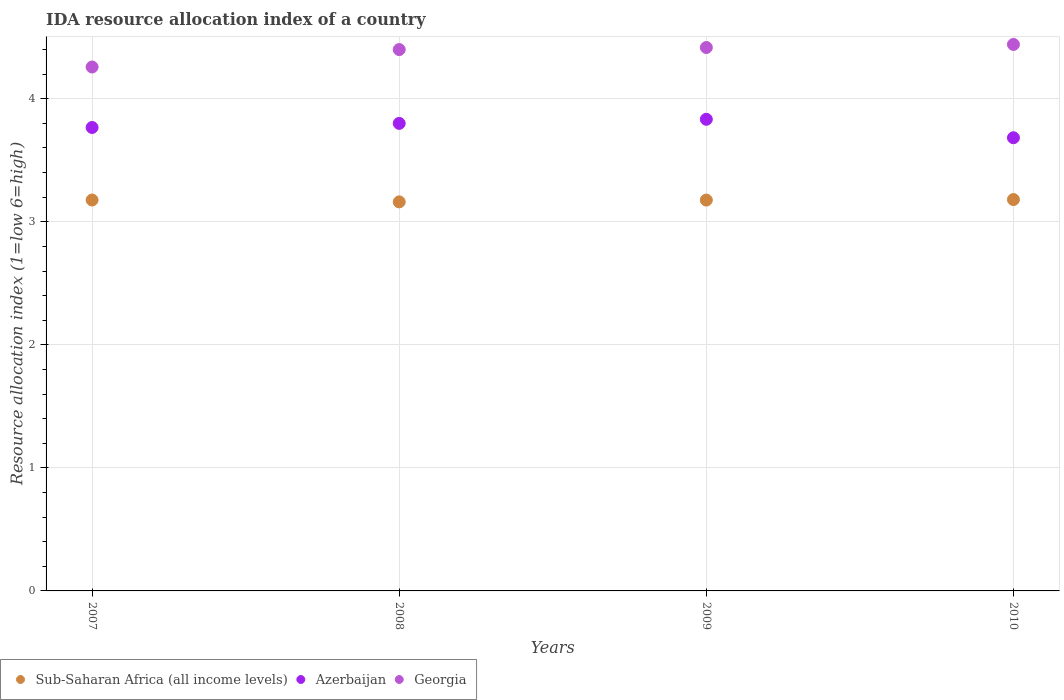What is the IDA resource allocation index in Azerbaijan in 2007?
Give a very brief answer. 3.77. Across all years, what is the maximum IDA resource allocation index in Azerbaijan?
Give a very brief answer. 3.83. Across all years, what is the minimum IDA resource allocation index in Sub-Saharan Africa (all income levels)?
Ensure brevity in your answer.  3.16. In which year was the IDA resource allocation index in Georgia maximum?
Your response must be concise. 2010. In which year was the IDA resource allocation index in Azerbaijan minimum?
Ensure brevity in your answer.  2010. What is the total IDA resource allocation index in Azerbaijan in the graph?
Offer a terse response. 15.08. What is the difference between the IDA resource allocation index in Azerbaijan in 2008 and that in 2009?
Ensure brevity in your answer.  -0.03. What is the difference between the IDA resource allocation index in Sub-Saharan Africa (all income levels) in 2010 and the IDA resource allocation index in Georgia in 2009?
Give a very brief answer. -1.24. What is the average IDA resource allocation index in Azerbaijan per year?
Make the answer very short. 3.77. In the year 2010, what is the difference between the IDA resource allocation index in Georgia and IDA resource allocation index in Azerbaijan?
Offer a terse response. 0.76. In how many years, is the IDA resource allocation index in Azerbaijan greater than 3.6?
Give a very brief answer. 4. What is the ratio of the IDA resource allocation index in Azerbaijan in 2008 to that in 2010?
Provide a short and direct response. 1.03. Is the IDA resource allocation index in Sub-Saharan Africa (all income levels) in 2007 less than that in 2010?
Give a very brief answer. Yes. What is the difference between the highest and the second highest IDA resource allocation index in Azerbaijan?
Your answer should be very brief. 0.03. What is the difference between the highest and the lowest IDA resource allocation index in Sub-Saharan Africa (all income levels)?
Ensure brevity in your answer.  0.02. Is it the case that in every year, the sum of the IDA resource allocation index in Azerbaijan and IDA resource allocation index in Sub-Saharan Africa (all income levels)  is greater than the IDA resource allocation index in Georgia?
Provide a succinct answer. Yes. Does the IDA resource allocation index in Georgia monotonically increase over the years?
Provide a short and direct response. Yes. Is the IDA resource allocation index in Azerbaijan strictly less than the IDA resource allocation index in Georgia over the years?
Keep it short and to the point. Yes. How many dotlines are there?
Give a very brief answer. 3. How many years are there in the graph?
Offer a terse response. 4. What is the difference between two consecutive major ticks on the Y-axis?
Provide a short and direct response. 1. How many legend labels are there?
Offer a very short reply. 3. How are the legend labels stacked?
Provide a succinct answer. Horizontal. What is the title of the graph?
Give a very brief answer. IDA resource allocation index of a country. Does "Malaysia" appear as one of the legend labels in the graph?
Your response must be concise. No. What is the label or title of the X-axis?
Offer a very short reply. Years. What is the label or title of the Y-axis?
Provide a succinct answer. Resource allocation index (1=low 6=high). What is the Resource allocation index (1=low 6=high) in Sub-Saharan Africa (all income levels) in 2007?
Keep it short and to the point. 3.18. What is the Resource allocation index (1=low 6=high) in Azerbaijan in 2007?
Ensure brevity in your answer.  3.77. What is the Resource allocation index (1=low 6=high) of Georgia in 2007?
Ensure brevity in your answer.  4.26. What is the Resource allocation index (1=low 6=high) of Sub-Saharan Africa (all income levels) in 2008?
Make the answer very short. 3.16. What is the Resource allocation index (1=low 6=high) in Azerbaijan in 2008?
Your answer should be very brief. 3.8. What is the Resource allocation index (1=low 6=high) in Georgia in 2008?
Your answer should be compact. 4.4. What is the Resource allocation index (1=low 6=high) of Sub-Saharan Africa (all income levels) in 2009?
Provide a short and direct response. 3.18. What is the Resource allocation index (1=low 6=high) of Azerbaijan in 2009?
Offer a terse response. 3.83. What is the Resource allocation index (1=low 6=high) of Georgia in 2009?
Offer a terse response. 4.42. What is the Resource allocation index (1=low 6=high) in Sub-Saharan Africa (all income levels) in 2010?
Keep it short and to the point. 3.18. What is the Resource allocation index (1=low 6=high) in Azerbaijan in 2010?
Your response must be concise. 3.68. What is the Resource allocation index (1=low 6=high) in Georgia in 2010?
Provide a short and direct response. 4.44. Across all years, what is the maximum Resource allocation index (1=low 6=high) in Sub-Saharan Africa (all income levels)?
Your response must be concise. 3.18. Across all years, what is the maximum Resource allocation index (1=low 6=high) in Azerbaijan?
Keep it short and to the point. 3.83. Across all years, what is the maximum Resource allocation index (1=low 6=high) in Georgia?
Your answer should be very brief. 4.44. Across all years, what is the minimum Resource allocation index (1=low 6=high) of Sub-Saharan Africa (all income levels)?
Your answer should be very brief. 3.16. Across all years, what is the minimum Resource allocation index (1=low 6=high) of Azerbaijan?
Give a very brief answer. 3.68. Across all years, what is the minimum Resource allocation index (1=low 6=high) of Georgia?
Provide a short and direct response. 4.26. What is the total Resource allocation index (1=low 6=high) in Sub-Saharan Africa (all income levels) in the graph?
Your response must be concise. 12.7. What is the total Resource allocation index (1=low 6=high) in Azerbaijan in the graph?
Make the answer very short. 15.08. What is the total Resource allocation index (1=low 6=high) of Georgia in the graph?
Your response must be concise. 17.52. What is the difference between the Resource allocation index (1=low 6=high) of Sub-Saharan Africa (all income levels) in 2007 and that in 2008?
Provide a short and direct response. 0.02. What is the difference between the Resource allocation index (1=low 6=high) in Azerbaijan in 2007 and that in 2008?
Offer a terse response. -0.03. What is the difference between the Resource allocation index (1=low 6=high) of Georgia in 2007 and that in 2008?
Offer a very short reply. -0.14. What is the difference between the Resource allocation index (1=low 6=high) of Sub-Saharan Africa (all income levels) in 2007 and that in 2009?
Keep it short and to the point. 0. What is the difference between the Resource allocation index (1=low 6=high) in Azerbaijan in 2007 and that in 2009?
Provide a succinct answer. -0.07. What is the difference between the Resource allocation index (1=low 6=high) in Georgia in 2007 and that in 2009?
Give a very brief answer. -0.16. What is the difference between the Resource allocation index (1=low 6=high) of Sub-Saharan Africa (all income levels) in 2007 and that in 2010?
Your response must be concise. -0. What is the difference between the Resource allocation index (1=low 6=high) of Azerbaijan in 2007 and that in 2010?
Your answer should be very brief. 0.08. What is the difference between the Resource allocation index (1=low 6=high) of Georgia in 2007 and that in 2010?
Provide a succinct answer. -0.18. What is the difference between the Resource allocation index (1=low 6=high) of Sub-Saharan Africa (all income levels) in 2008 and that in 2009?
Your response must be concise. -0.01. What is the difference between the Resource allocation index (1=low 6=high) in Azerbaijan in 2008 and that in 2009?
Provide a succinct answer. -0.03. What is the difference between the Resource allocation index (1=low 6=high) of Georgia in 2008 and that in 2009?
Your answer should be compact. -0.02. What is the difference between the Resource allocation index (1=low 6=high) of Sub-Saharan Africa (all income levels) in 2008 and that in 2010?
Provide a short and direct response. -0.02. What is the difference between the Resource allocation index (1=low 6=high) of Azerbaijan in 2008 and that in 2010?
Offer a very short reply. 0.12. What is the difference between the Resource allocation index (1=low 6=high) in Georgia in 2008 and that in 2010?
Offer a very short reply. -0.04. What is the difference between the Resource allocation index (1=low 6=high) in Sub-Saharan Africa (all income levels) in 2009 and that in 2010?
Provide a succinct answer. -0. What is the difference between the Resource allocation index (1=low 6=high) of Georgia in 2009 and that in 2010?
Offer a very short reply. -0.03. What is the difference between the Resource allocation index (1=low 6=high) of Sub-Saharan Africa (all income levels) in 2007 and the Resource allocation index (1=low 6=high) of Azerbaijan in 2008?
Give a very brief answer. -0.62. What is the difference between the Resource allocation index (1=low 6=high) in Sub-Saharan Africa (all income levels) in 2007 and the Resource allocation index (1=low 6=high) in Georgia in 2008?
Give a very brief answer. -1.22. What is the difference between the Resource allocation index (1=low 6=high) of Azerbaijan in 2007 and the Resource allocation index (1=low 6=high) of Georgia in 2008?
Your answer should be very brief. -0.63. What is the difference between the Resource allocation index (1=low 6=high) in Sub-Saharan Africa (all income levels) in 2007 and the Resource allocation index (1=low 6=high) in Azerbaijan in 2009?
Your response must be concise. -0.66. What is the difference between the Resource allocation index (1=low 6=high) in Sub-Saharan Africa (all income levels) in 2007 and the Resource allocation index (1=low 6=high) in Georgia in 2009?
Offer a very short reply. -1.24. What is the difference between the Resource allocation index (1=low 6=high) of Azerbaijan in 2007 and the Resource allocation index (1=low 6=high) of Georgia in 2009?
Ensure brevity in your answer.  -0.65. What is the difference between the Resource allocation index (1=low 6=high) in Sub-Saharan Africa (all income levels) in 2007 and the Resource allocation index (1=low 6=high) in Azerbaijan in 2010?
Ensure brevity in your answer.  -0.51. What is the difference between the Resource allocation index (1=low 6=high) of Sub-Saharan Africa (all income levels) in 2007 and the Resource allocation index (1=low 6=high) of Georgia in 2010?
Provide a short and direct response. -1.26. What is the difference between the Resource allocation index (1=low 6=high) in Azerbaijan in 2007 and the Resource allocation index (1=low 6=high) in Georgia in 2010?
Your response must be concise. -0.68. What is the difference between the Resource allocation index (1=low 6=high) of Sub-Saharan Africa (all income levels) in 2008 and the Resource allocation index (1=low 6=high) of Azerbaijan in 2009?
Your answer should be very brief. -0.67. What is the difference between the Resource allocation index (1=low 6=high) in Sub-Saharan Africa (all income levels) in 2008 and the Resource allocation index (1=low 6=high) in Georgia in 2009?
Your answer should be compact. -1.25. What is the difference between the Resource allocation index (1=low 6=high) of Azerbaijan in 2008 and the Resource allocation index (1=low 6=high) of Georgia in 2009?
Your answer should be very brief. -0.62. What is the difference between the Resource allocation index (1=low 6=high) of Sub-Saharan Africa (all income levels) in 2008 and the Resource allocation index (1=low 6=high) of Azerbaijan in 2010?
Your answer should be compact. -0.52. What is the difference between the Resource allocation index (1=low 6=high) of Sub-Saharan Africa (all income levels) in 2008 and the Resource allocation index (1=low 6=high) of Georgia in 2010?
Offer a terse response. -1.28. What is the difference between the Resource allocation index (1=low 6=high) in Azerbaijan in 2008 and the Resource allocation index (1=low 6=high) in Georgia in 2010?
Your response must be concise. -0.64. What is the difference between the Resource allocation index (1=low 6=high) of Sub-Saharan Africa (all income levels) in 2009 and the Resource allocation index (1=low 6=high) of Azerbaijan in 2010?
Your response must be concise. -0.51. What is the difference between the Resource allocation index (1=low 6=high) of Sub-Saharan Africa (all income levels) in 2009 and the Resource allocation index (1=low 6=high) of Georgia in 2010?
Ensure brevity in your answer.  -1.26. What is the difference between the Resource allocation index (1=low 6=high) in Azerbaijan in 2009 and the Resource allocation index (1=low 6=high) in Georgia in 2010?
Keep it short and to the point. -0.61. What is the average Resource allocation index (1=low 6=high) in Sub-Saharan Africa (all income levels) per year?
Ensure brevity in your answer.  3.17. What is the average Resource allocation index (1=low 6=high) of Azerbaijan per year?
Keep it short and to the point. 3.77. What is the average Resource allocation index (1=low 6=high) of Georgia per year?
Make the answer very short. 4.38. In the year 2007, what is the difference between the Resource allocation index (1=low 6=high) of Sub-Saharan Africa (all income levels) and Resource allocation index (1=low 6=high) of Azerbaijan?
Your response must be concise. -0.59. In the year 2007, what is the difference between the Resource allocation index (1=low 6=high) of Sub-Saharan Africa (all income levels) and Resource allocation index (1=low 6=high) of Georgia?
Your answer should be compact. -1.08. In the year 2007, what is the difference between the Resource allocation index (1=low 6=high) in Azerbaijan and Resource allocation index (1=low 6=high) in Georgia?
Keep it short and to the point. -0.49. In the year 2008, what is the difference between the Resource allocation index (1=low 6=high) of Sub-Saharan Africa (all income levels) and Resource allocation index (1=low 6=high) of Azerbaijan?
Make the answer very short. -0.64. In the year 2008, what is the difference between the Resource allocation index (1=low 6=high) in Sub-Saharan Africa (all income levels) and Resource allocation index (1=low 6=high) in Georgia?
Ensure brevity in your answer.  -1.24. In the year 2008, what is the difference between the Resource allocation index (1=low 6=high) of Azerbaijan and Resource allocation index (1=low 6=high) of Georgia?
Your answer should be very brief. -0.6. In the year 2009, what is the difference between the Resource allocation index (1=low 6=high) in Sub-Saharan Africa (all income levels) and Resource allocation index (1=low 6=high) in Azerbaijan?
Provide a short and direct response. -0.66. In the year 2009, what is the difference between the Resource allocation index (1=low 6=high) in Sub-Saharan Africa (all income levels) and Resource allocation index (1=low 6=high) in Georgia?
Give a very brief answer. -1.24. In the year 2009, what is the difference between the Resource allocation index (1=low 6=high) in Azerbaijan and Resource allocation index (1=low 6=high) in Georgia?
Ensure brevity in your answer.  -0.58. In the year 2010, what is the difference between the Resource allocation index (1=low 6=high) of Sub-Saharan Africa (all income levels) and Resource allocation index (1=low 6=high) of Azerbaijan?
Provide a short and direct response. -0.5. In the year 2010, what is the difference between the Resource allocation index (1=low 6=high) of Sub-Saharan Africa (all income levels) and Resource allocation index (1=low 6=high) of Georgia?
Make the answer very short. -1.26. In the year 2010, what is the difference between the Resource allocation index (1=low 6=high) in Azerbaijan and Resource allocation index (1=low 6=high) in Georgia?
Make the answer very short. -0.76. What is the ratio of the Resource allocation index (1=low 6=high) of Azerbaijan in 2007 to that in 2008?
Make the answer very short. 0.99. What is the ratio of the Resource allocation index (1=low 6=high) of Georgia in 2007 to that in 2008?
Give a very brief answer. 0.97. What is the ratio of the Resource allocation index (1=low 6=high) of Azerbaijan in 2007 to that in 2009?
Ensure brevity in your answer.  0.98. What is the ratio of the Resource allocation index (1=low 6=high) of Georgia in 2007 to that in 2009?
Provide a succinct answer. 0.96. What is the ratio of the Resource allocation index (1=low 6=high) in Azerbaijan in 2007 to that in 2010?
Your response must be concise. 1.02. What is the ratio of the Resource allocation index (1=low 6=high) in Georgia in 2007 to that in 2010?
Give a very brief answer. 0.96. What is the ratio of the Resource allocation index (1=low 6=high) of Sub-Saharan Africa (all income levels) in 2008 to that in 2009?
Your answer should be very brief. 1. What is the ratio of the Resource allocation index (1=low 6=high) in Azerbaijan in 2008 to that in 2010?
Provide a succinct answer. 1.03. What is the ratio of the Resource allocation index (1=low 6=high) in Georgia in 2008 to that in 2010?
Make the answer very short. 0.99. What is the ratio of the Resource allocation index (1=low 6=high) of Sub-Saharan Africa (all income levels) in 2009 to that in 2010?
Offer a very short reply. 1. What is the ratio of the Resource allocation index (1=low 6=high) in Azerbaijan in 2009 to that in 2010?
Make the answer very short. 1.04. What is the ratio of the Resource allocation index (1=low 6=high) in Georgia in 2009 to that in 2010?
Offer a very short reply. 0.99. What is the difference between the highest and the second highest Resource allocation index (1=low 6=high) in Sub-Saharan Africa (all income levels)?
Give a very brief answer. 0. What is the difference between the highest and the second highest Resource allocation index (1=low 6=high) of Azerbaijan?
Offer a very short reply. 0.03. What is the difference between the highest and the second highest Resource allocation index (1=low 6=high) in Georgia?
Provide a short and direct response. 0.03. What is the difference between the highest and the lowest Resource allocation index (1=low 6=high) in Sub-Saharan Africa (all income levels)?
Your response must be concise. 0.02. What is the difference between the highest and the lowest Resource allocation index (1=low 6=high) of Georgia?
Offer a terse response. 0.18. 